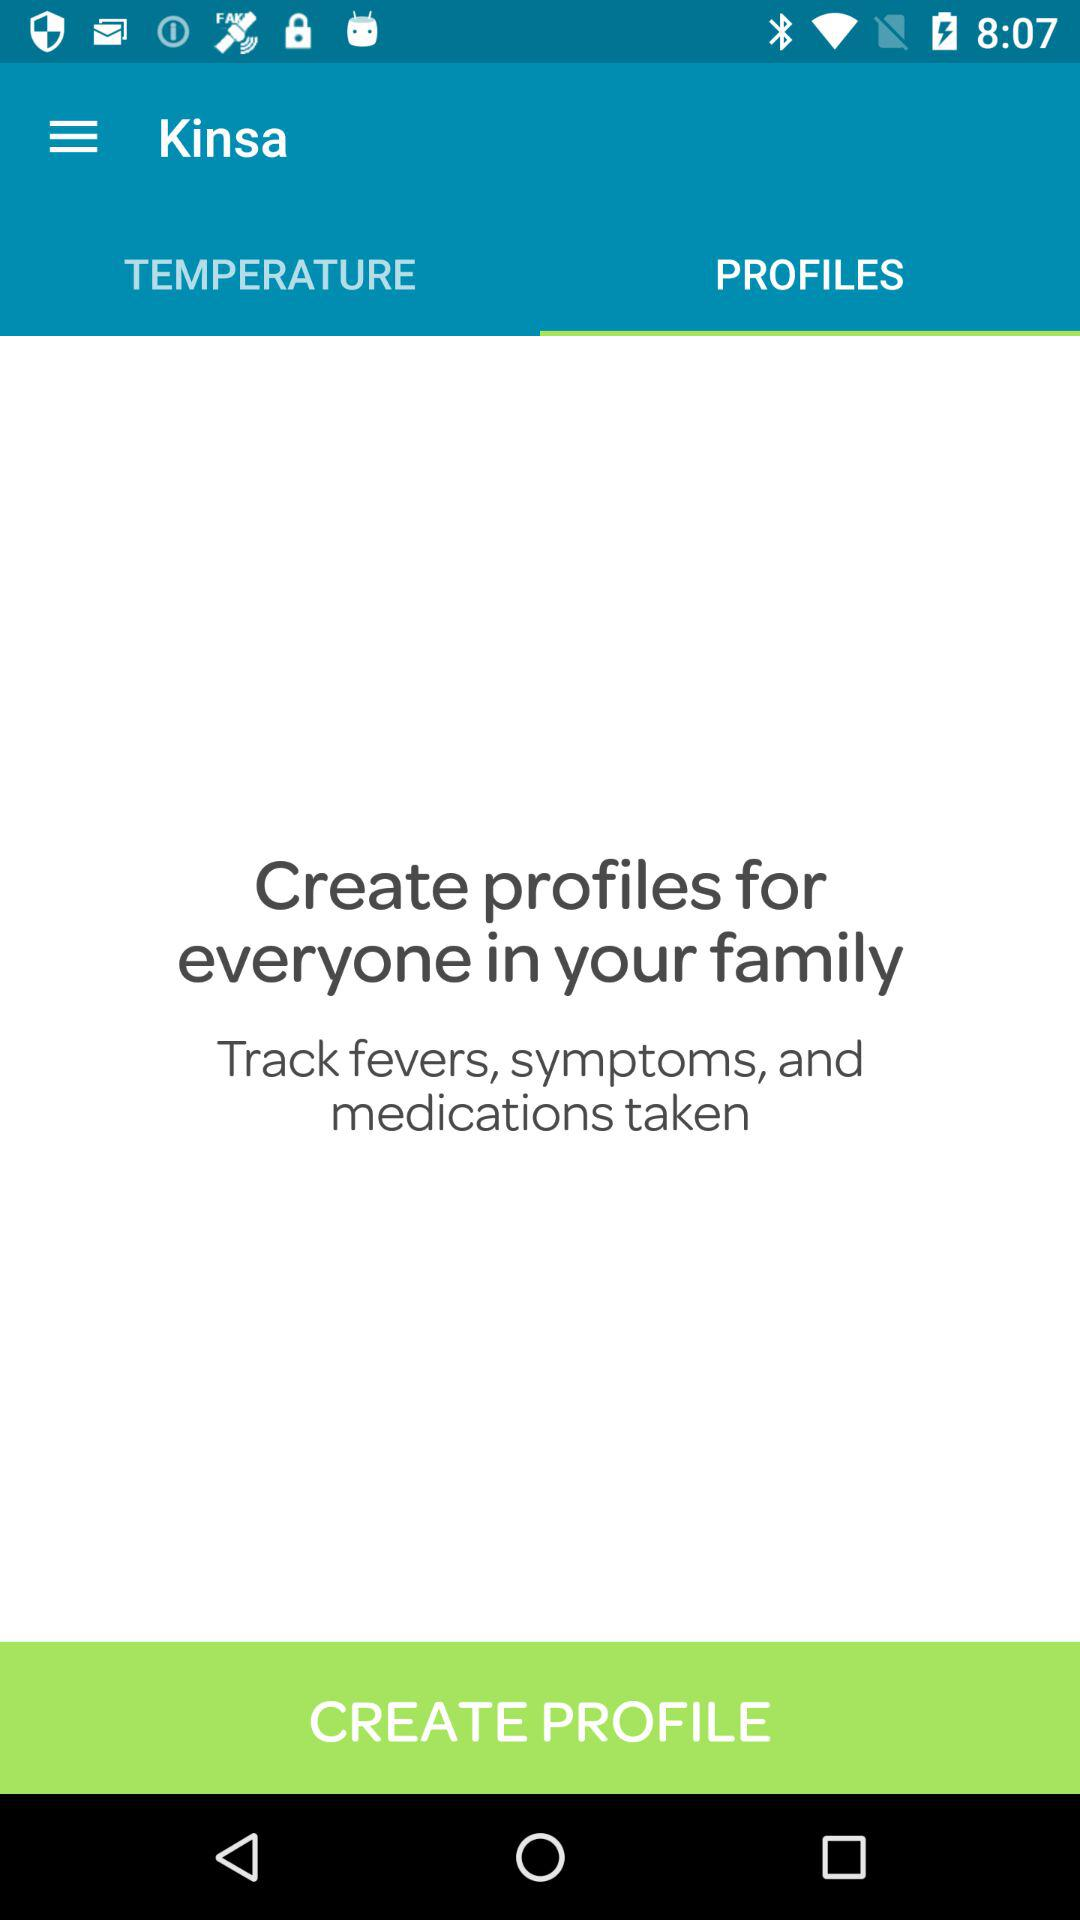What is the name of the application? The name of the application is "Kinsa". 